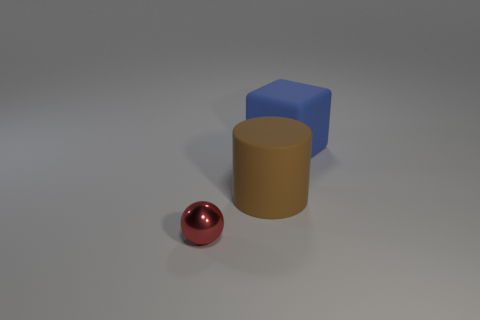Add 2 blue rubber cubes. How many objects exist? 5 Subtract 0 yellow cylinders. How many objects are left? 3 Subtract all blocks. How many objects are left? 2 Subtract all cylinders. Subtract all large brown matte objects. How many objects are left? 1 Add 1 matte cylinders. How many matte cylinders are left? 2 Add 2 red objects. How many red objects exist? 3 